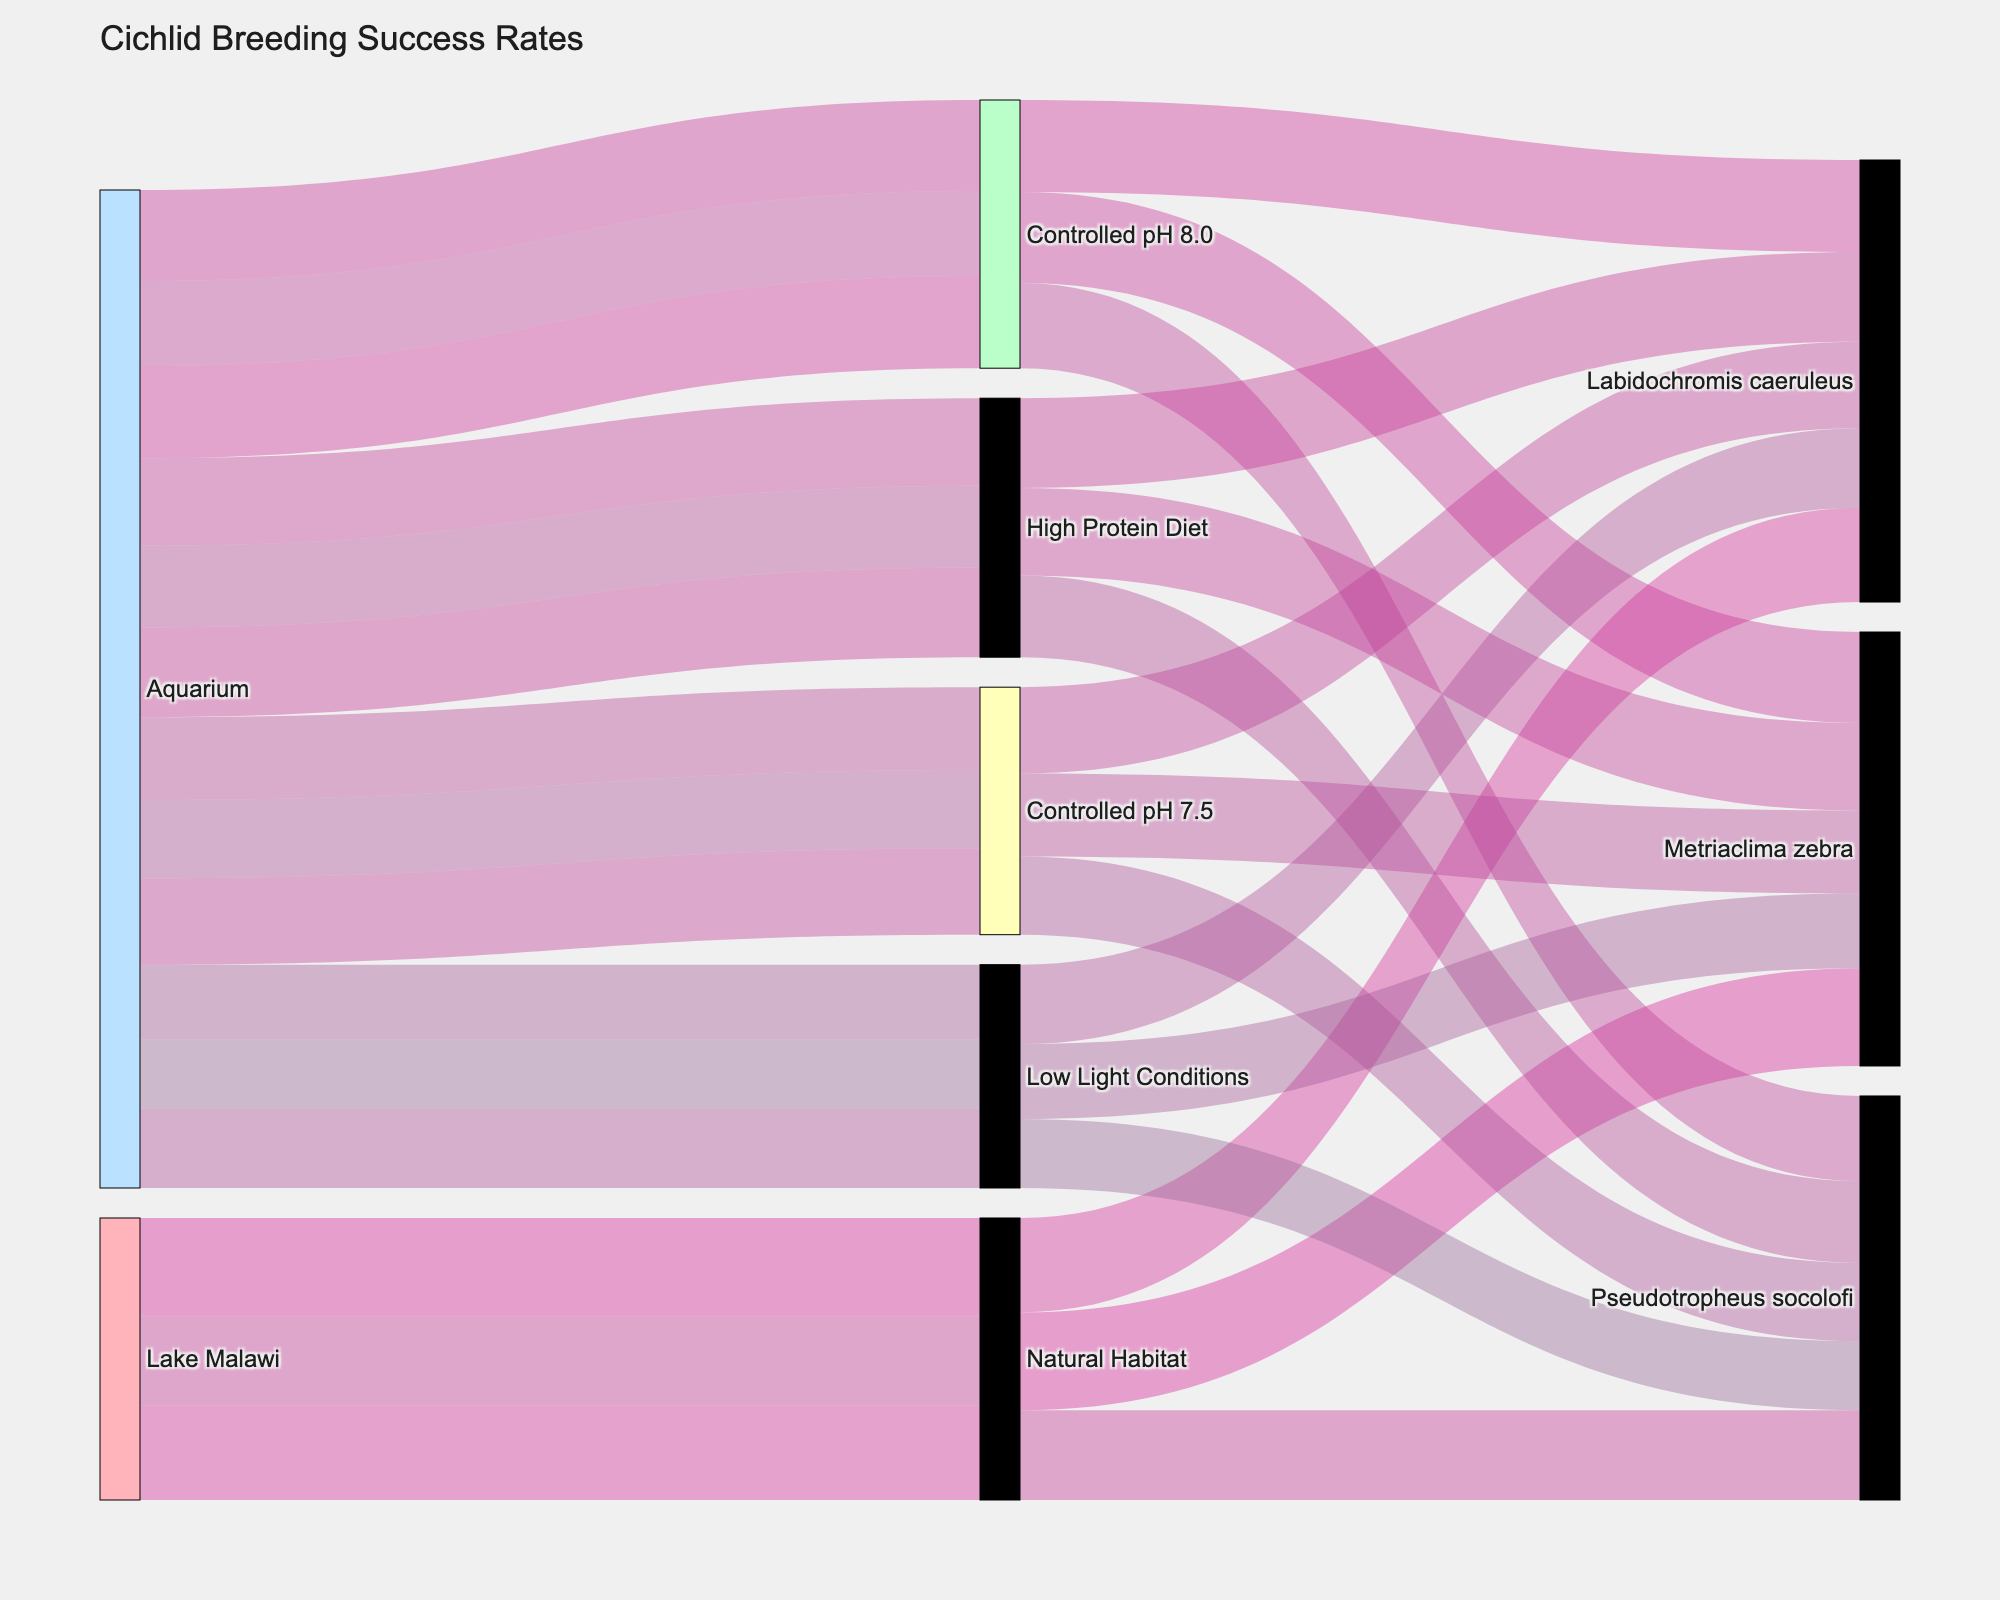What's the highest breeding success rate for Metriaclima zebra across all conditions? To find the highest breeding success rate for Metriaclima zebra, we look at its values under different conditions. They are 85, 72, 79, 76, and 65. The highest among these is 85.
Answer: 85 Which species had the lowest breeding success rate under low light conditions? To determine this, look at the success rates for all species under low light conditions: Metriaclima zebra (65), Pseudotropheus socolofi (60), and Labidochromis caeruleus (69). The lowest is Pseudotropheus socolofi with a success rate of 60.
Answer: Pseudotropheus socolofi What is the difference in breeding success rate for Labidochromis caeruleus between natural habitat and controlled pH 7.5? Labidochromis caeruleus has a success rate of 82 in a natural habitat and 75 in controlled pH 7.5. The difference is 82 - 75 = 7.
Answer: 7 What’s the average breeding success rate in controlled pH 8.0 conditions? The breeding success rates in controlled pH 8.0 conditions are: Metriaclima zebra (79), Pseudotropheus socolofi (74), and Labidochromis caeruleus (80). The average is (79 + 74 + 80) / 3 = 77.67.
Answer: 77.67 Which condition leads to the lowest overall breeding success rate? To find this, compare the average success rates of each condition. Calculate the average for each and compare. The averages are: Natural Habitat (81.67), Controlled pH 7.5 (71.67), Controlled pH 8.0 (77.67), High Protein Diet (75), Low Light Conditions (64.67). The lowest is Low Light Conditions with 64.67.
Answer: Low Light Conditions Does Pseudotropheus socolofi have a higher breeding success rate in controlled pH 8.0 or high protein diet conditions? Compare the success rates: Controlled pH 8.0 (74), High Protein Diet (71). It is higher in Controlled pH 8.0.
Answer: Controlled pH 8.0 What proportion of total breeding success rates in a natural habitat is contributed by Metriaclima zebra? Calculate the proportion using Metriaclima zebra's success rate (85) and the total for all species in natural habitat (85 + 78 + 82 = 245). The proportion is 85 / 245 ≈ 0.347.
Answer: 34.7% How does the breeding success rate of Labidochromis caeruleus compare between high protein diet and low light conditions? Compare the success rates: High Protein Diet (78) vs. Low Light Conditions (69). High Protein Diet results in a higher success rate.
Answer: High Protein Diet 